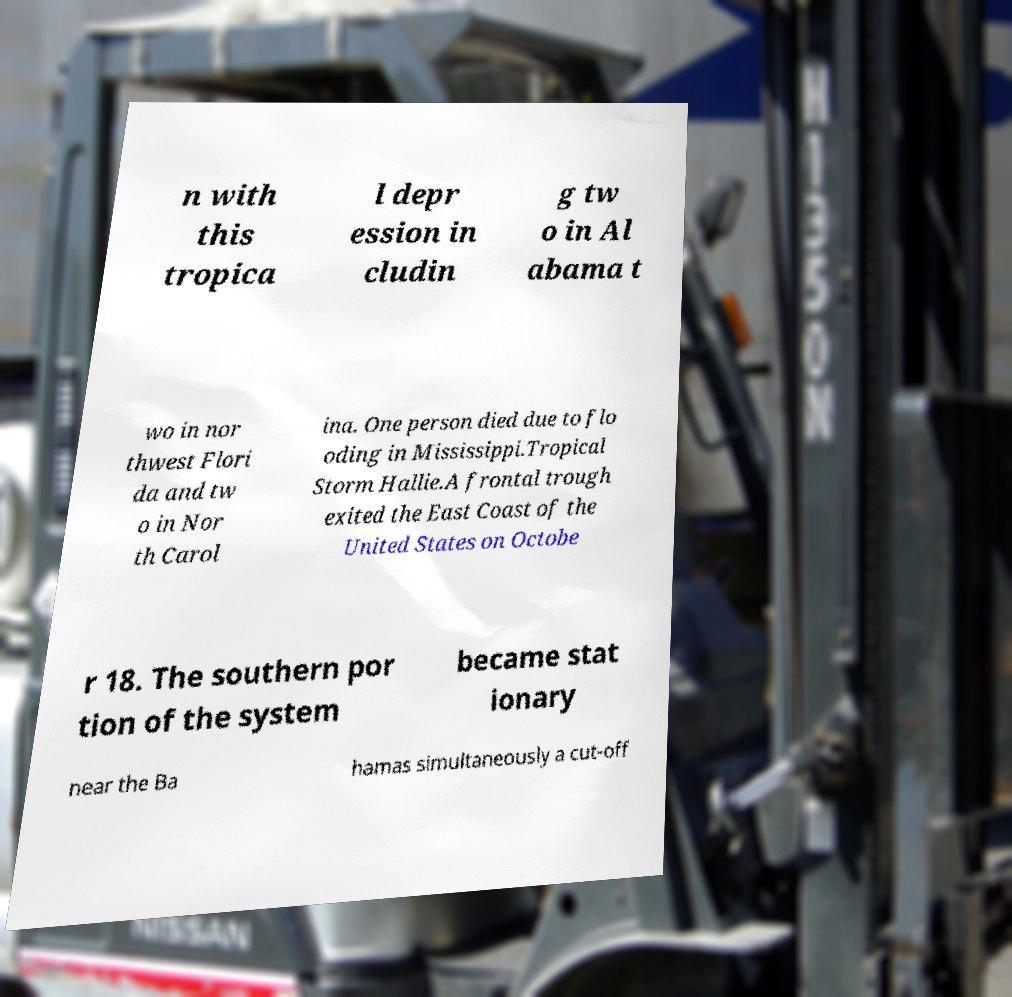There's text embedded in this image that I need extracted. Can you transcribe it verbatim? n with this tropica l depr ession in cludin g tw o in Al abama t wo in nor thwest Flori da and tw o in Nor th Carol ina. One person died due to flo oding in Mississippi.Tropical Storm Hallie.A frontal trough exited the East Coast of the United States on Octobe r 18. The southern por tion of the system became stat ionary near the Ba hamas simultaneously a cut-off 